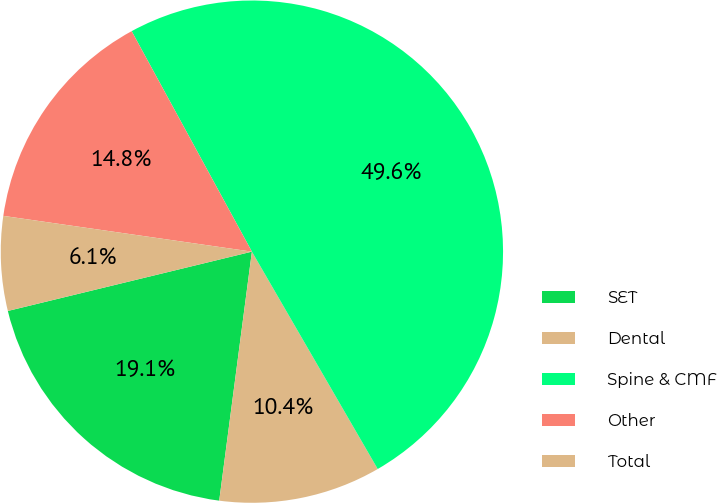<chart> <loc_0><loc_0><loc_500><loc_500><pie_chart><fcel>SET<fcel>Dental<fcel>Spine & CMF<fcel>Other<fcel>Total<nl><fcel>19.13%<fcel>10.43%<fcel>49.6%<fcel>14.78%<fcel>6.07%<nl></chart> 